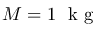Convert formula to latex. <formula><loc_0><loc_0><loc_500><loc_500>M = 1 k g</formula> 